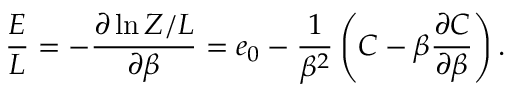Convert formula to latex. <formula><loc_0><loc_0><loc_500><loc_500>{ \frac { E } { L } } = - { \frac { \partial \ln Z / L } { \partial \beta } } = e _ { 0 } - { \frac { 1 } { \beta ^ { 2 } } } \left ( C - \beta { \frac { \partial C } { \partial \beta } } \right ) .</formula> 